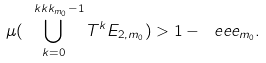Convert formula to latex. <formula><loc_0><loc_0><loc_500><loc_500>\mu ( \bigcup _ { k = 0 } ^ { \ k k k _ { m _ { 0 } } - 1 } T ^ { k } E _ { 2 , m _ { 0 } } ) > 1 - \ e e e _ { m _ { 0 } } .</formula> 